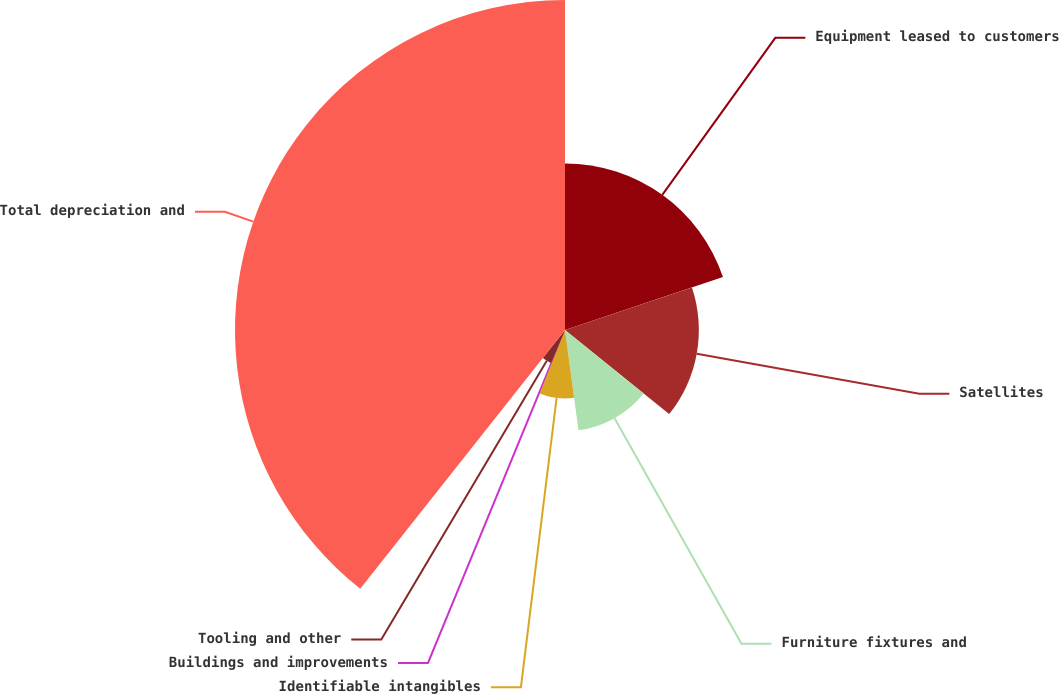<chart> <loc_0><loc_0><loc_500><loc_500><pie_chart><fcel>Equipment leased to customers<fcel>Satellites<fcel>Furniture fixtures and<fcel>Identifiable intangibles<fcel>Buildings and improvements<fcel>Tooling and other<fcel>Total depreciation and<nl><fcel>19.86%<fcel>15.96%<fcel>12.06%<fcel>8.16%<fcel>0.36%<fcel>4.26%<fcel>39.35%<nl></chart> 